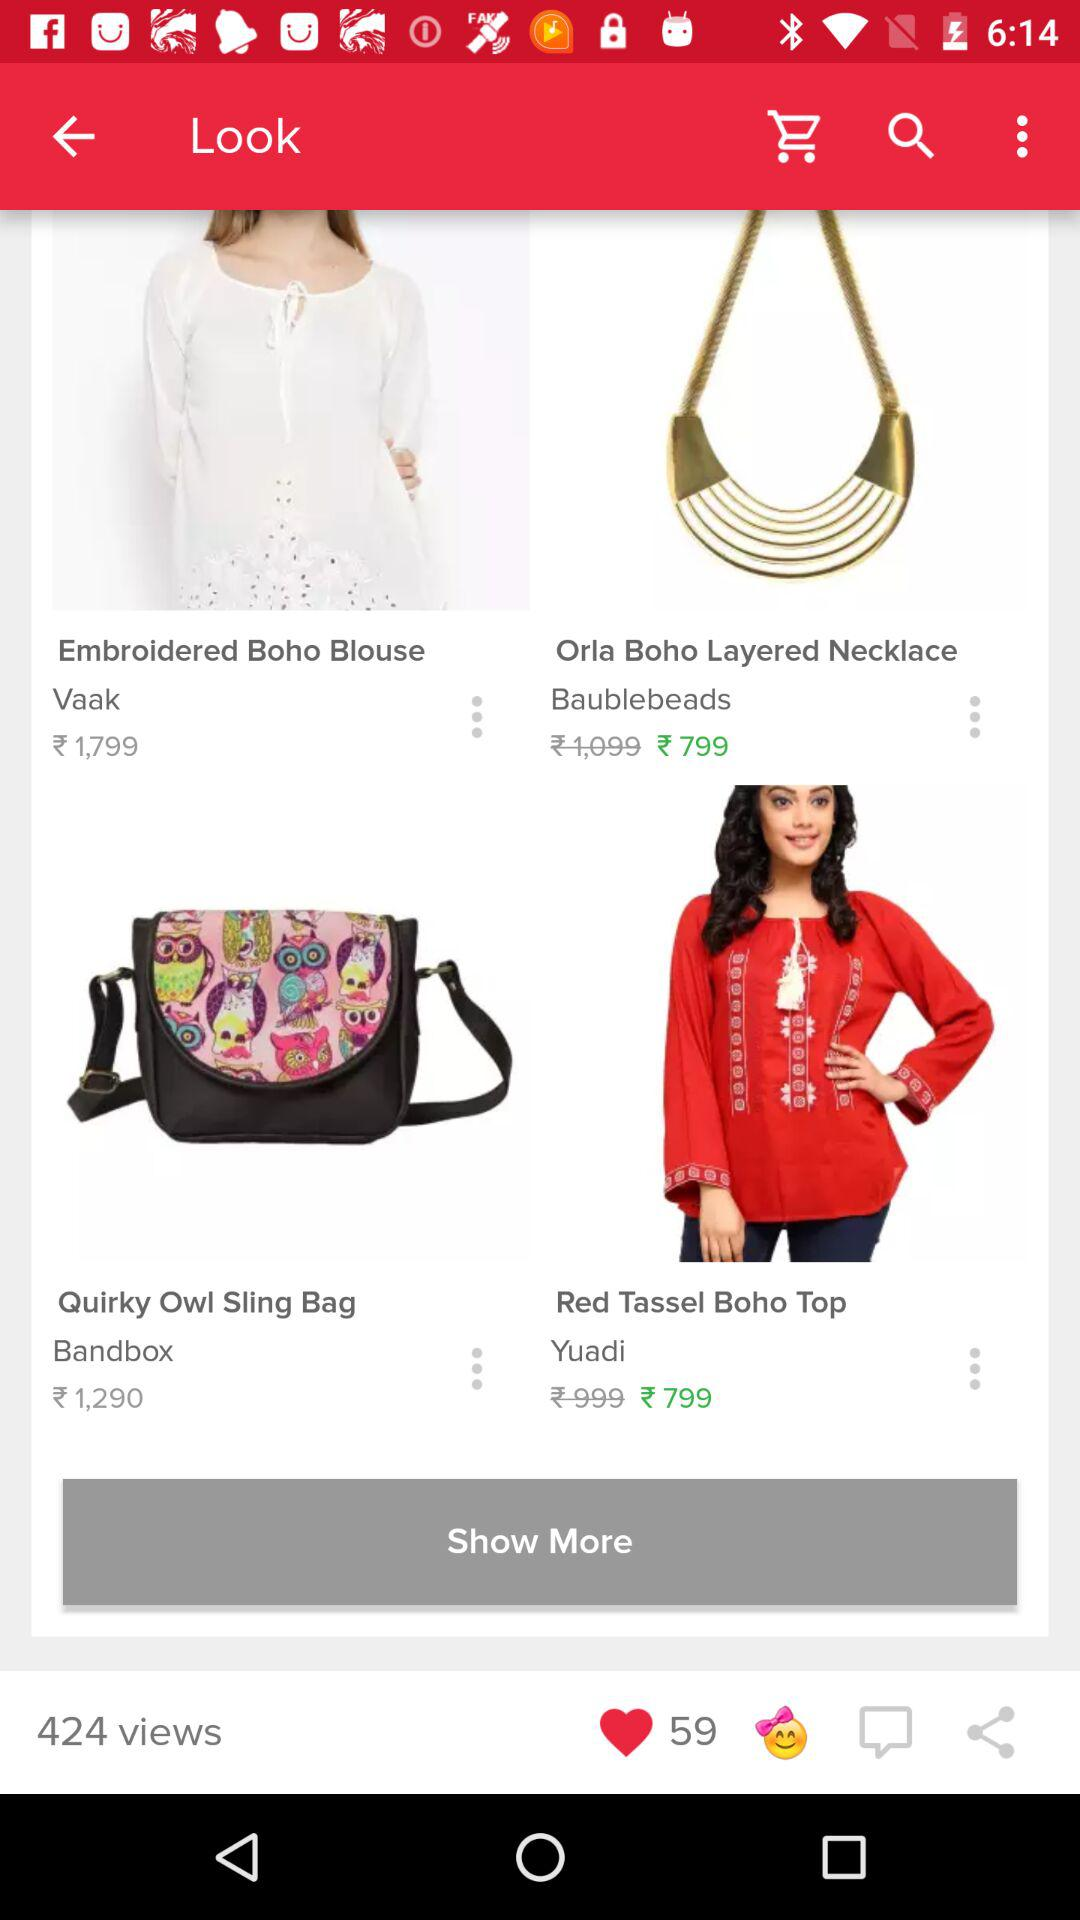What is the price of the embroidered boho blouse? The price is ₹1,799. 